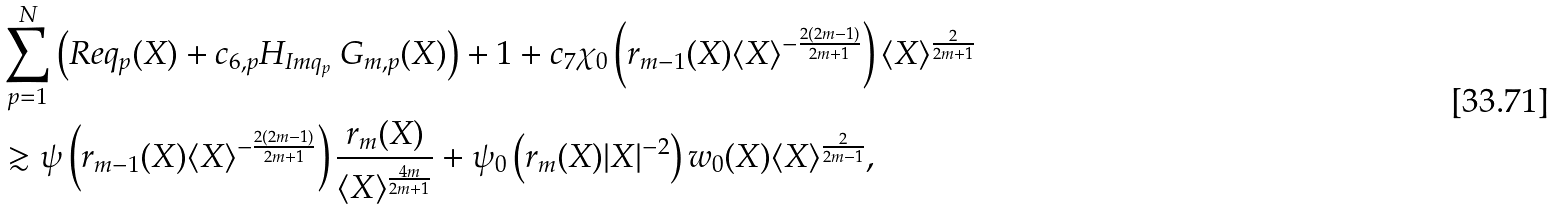Convert formula to latex. <formula><loc_0><loc_0><loc_500><loc_500>& \ \sum _ { p = 1 } ^ { N } \left ( R e q _ { p } ( X ) + c _ { 6 , p } H _ { I m q _ { p } } \ G _ { m , p } ( X ) \right ) + 1 + c _ { 7 } \chi _ { 0 } \left ( r _ { m - 1 } ( X ) \langle X \rangle ^ { - \frac { 2 ( 2 m - 1 ) } { 2 m + 1 } } \right ) \langle X \rangle ^ { \frac { 2 } { 2 m + 1 } } \\ & \ \gtrsim \psi \left ( r _ { m - 1 } ( X ) \langle X \rangle ^ { - \frac { 2 ( 2 m - 1 ) } { 2 m + 1 } } \right ) \frac { r _ { m } ( X ) } { \langle X \rangle ^ { \frac { 4 m } { 2 m + 1 } } } + \psi _ { 0 } \left ( r _ { m } ( X ) | X | ^ { - 2 } \right ) w _ { 0 } ( X ) \langle X \rangle ^ { \frac { 2 } { 2 m - 1 } } ,</formula> 